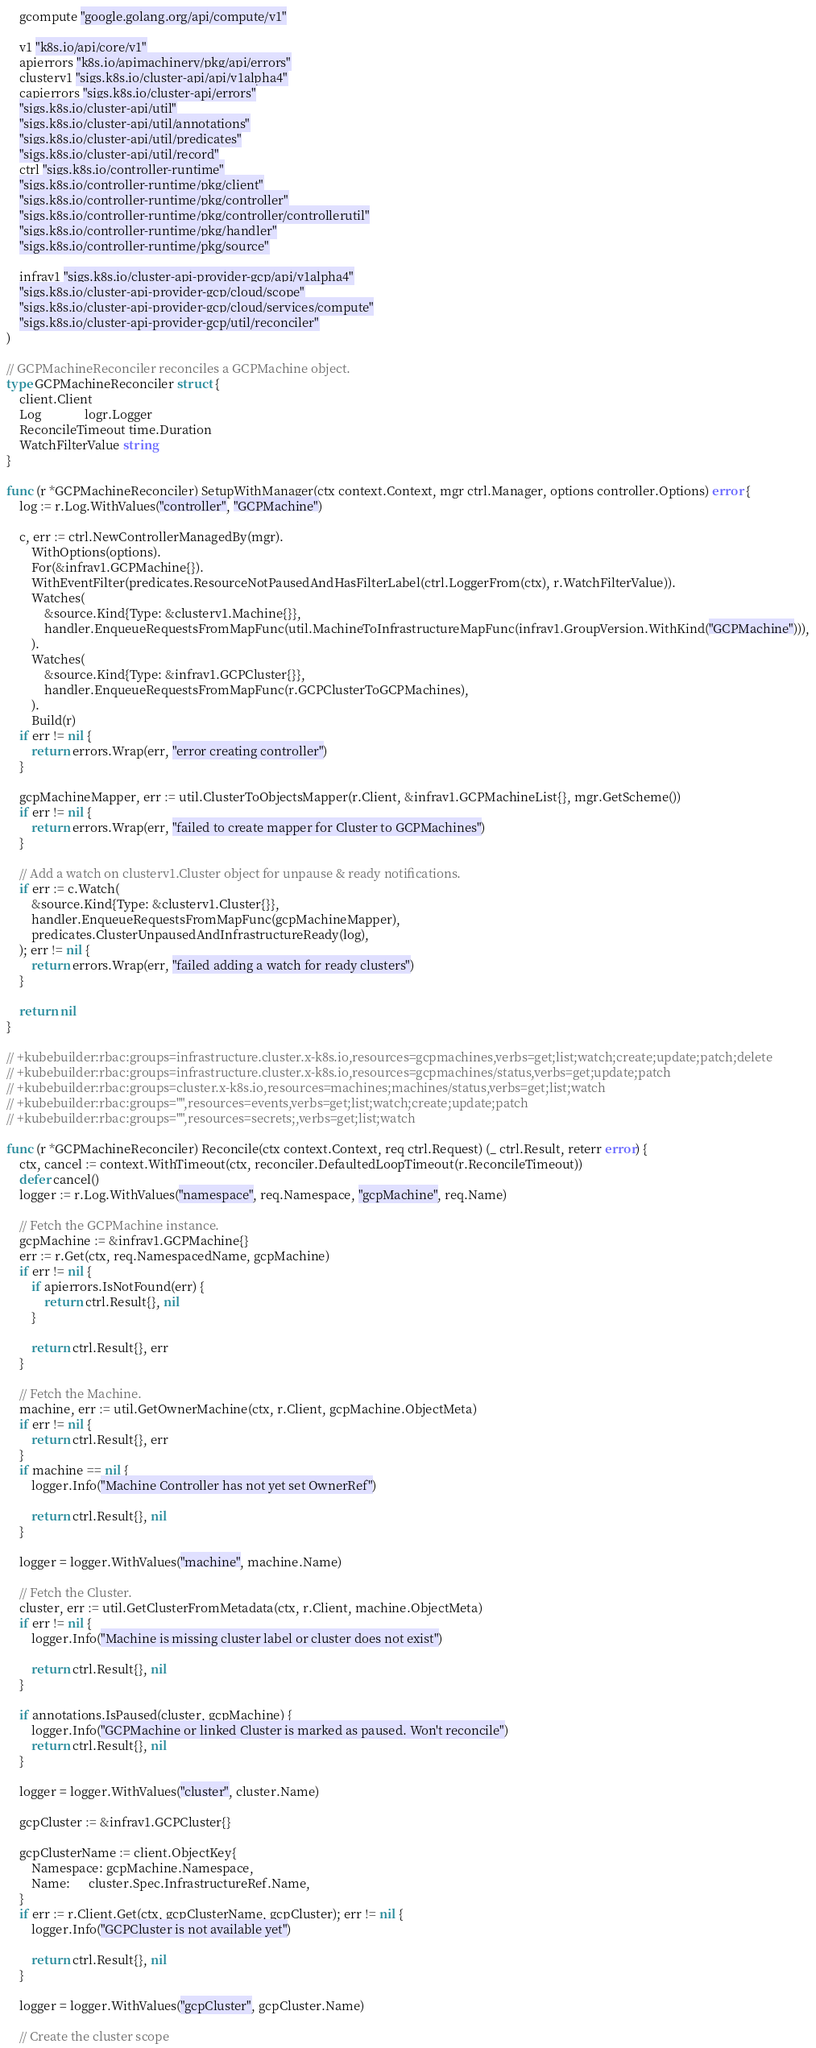Convert code to text. <code><loc_0><loc_0><loc_500><loc_500><_Go_>	gcompute "google.golang.org/api/compute/v1"

	v1 "k8s.io/api/core/v1"
	apierrors "k8s.io/apimachinery/pkg/api/errors"
	clusterv1 "sigs.k8s.io/cluster-api/api/v1alpha4"
	capierrors "sigs.k8s.io/cluster-api/errors"
	"sigs.k8s.io/cluster-api/util"
	"sigs.k8s.io/cluster-api/util/annotations"
	"sigs.k8s.io/cluster-api/util/predicates"
	"sigs.k8s.io/cluster-api/util/record"
	ctrl "sigs.k8s.io/controller-runtime"
	"sigs.k8s.io/controller-runtime/pkg/client"
	"sigs.k8s.io/controller-runtime/pkg/controller"
	"sigs.k8s.io/controller-runtime/pkg/controller/controllerutil"
	"sigs.k8s.io/controller-runtime/pkg/handler"
	"sigs.k8s.io/controller-runtime/pkg/source"

	infrav1 "sigs.k8s.io/cluster-api-provider-gcp/api/v1alpha4"
	"sigs.k8s.io/cluster-api-provider-gcp/cloud/scope"
	"sigs.k8s.io/cluster-api-provider-gcp/cloud/services/compute"
	"sigs.k8s.io/cluster-api-provider-gcp/util/reconciler"
)

// GCPMachineReconciler reconciles a GCPMachine object.
type GCPMachineReconciler struct {
	client.Client
	Log              logr.Logger
	ReconcileTimeout time.Duration
	WatchFilterValue string
}

func (r *GCPMachineReconciler) SetupWithManager(ctx context.Context, mgr ctrl.Manager, options controller.Options) error {
	log := r.Log.WithValues("controller", "GCPMachine")

	c, err := ctrl.NewControllerManagedBy(mgr).
		WithOptions(options).
		For(&infrav1.GCPMachine{}).
		WithEventFilter(predicates.ResourceNotPausedAndHasFilterLabel(ctrl.LoggerFrom(ctx), r.WatchFilterValue)).
		Watches(
			&source.Kind{Type: &clusterv1.Machine{}},
			handler.EnqueueRequestsFromMapFunc(util.MachineToInfrastructureMapFunc(infrav1.GroupVersion.WithKind("GCPMachine"))),
		).
		Watches(
			&source.Kind{Type: &infrav1.GCPCluster{}},
			handler.EnqueueRequestsFromMapFunc(r.GCPClusterToGCPMachines),
		).
		Build(r)
	if err != nil {
		return errors.Wrap(err, "error creating controller")
	}

	gcpMachineMapper, err := util.ClusterToObjectsMapper(r.Client, &infrav1.GCPMachineList{}, mgr.GetScheme())
	if err != nil {
		return errors.Wrap(err, "failed to create mapper for Cluster to GCPMachines")
	}

	// Add a watch on clusterv1.Cluster object for unpause & ready notifications.
	if err := c.Watch(
		&source.Kind{Type: &clusterv1.Cluster{}},
		handler.EnqueueRequestsFromMapFunc(gcpMachineMapper),
		predicates.ClusterUnpausedAndInfrastructureReady(log),
	); err != nil {
		return errors.Wrap(err, "failed adding a watch for ready clusters")
	}

	return nil
}

// +kubebuilder:rbac:groups=infrastructure.cluster.x-k8s.io,resources=gcpmachines,verbs=get;list;watch;create;update;patch;delete
// +kubebuilder:rbac:groups=infrastructure.cluster.x-k8s.io,resources=gcpmachines/status,verbs=get;update;patch
// +kubebuilder:rbac:groups=cluster.x-k8s.io,resources=machines;machines/status,verbs=get;list;watch
// +kubebuilder:rbac:groups="",resources=events,verbs=get;list;watch;create;update;patch
// +kubebuilder:rbac:groups="",resources=secrets;,verbs=get;list;watch

func (r *GCPMachineReconciler) Reconcile(ctx context.Context, req ctrl.Request) (_ ctrl.Result, reterr error) {
	ctx, cancel := context.WithTimeout(ctx, reconciler.DefaultedLoopTimeout(r.ReconcileTimeout))
	defer cancel()
	logger := r.Log.WithValues("namespace", req.Namespace, "gcpMachine", req.Name)

	// Fetch the GCPMachine instance.
	gcpMachine := &infrav1.GCPMachine{}
	err := r.Get(ctx, req.NamespacedName, gcpMachine)
	if err != nil {
		if apierrors.IsNotFound(err) {
			return ctrl.Result{}, nil
		}

		return ctrl.Result{}, err
	}

	// Fetch the Machine.
	machine, err := util.GetOwnerMachine(ctx, r.Client, gcpMachine.ObjectMeta)
	if err != nil {
		return ctrl.Result{}, err
	}
	if machine == nil {
		logger.Info("Machine Controller has not yet set OwnerRef")

		return ctrl.Result{}, nil
	}

	logger = logger.WithValues("machine", machine.Name)

	// Fetch the Cluster.
	cluster, err := util.GetClusterFromMetadata(ctx, r.Client, machine.ObjectMeta)
	if err != nil {
		logger.Info("Machine is missing cluster label or cluster does not exist")

		return ctrl.Result{}, nil
	}

	if annotations.IsPaused(cluster, gcpMachine) {
		logger.Info("GCPMachine or linked Cluster is marked as paused. Won't reconcile")
		return ctrl.Result{}, nil
	}

	logger = logger.WithValues("cluster", cluster.Name)

	gcpCluster := &infrav1.GCPCluster{}

	gcpClusterName := client.ObjectKey{
		Namespace: gcpMachine.Namespace,
		Name:      cluster.Spec.InfrastructureRef.Name,
	}
	if err := r.Client.Get(ctx, gcpClusterName, gcpCluster); err != nil {
		logger.Info("GCPCluster is not available yet")

		return ctrl.Result{}, nil
	}

	logger = logger.WithValues("gcpCluster", gcpCluster.Name)

	// Create the cluster scope</code> 